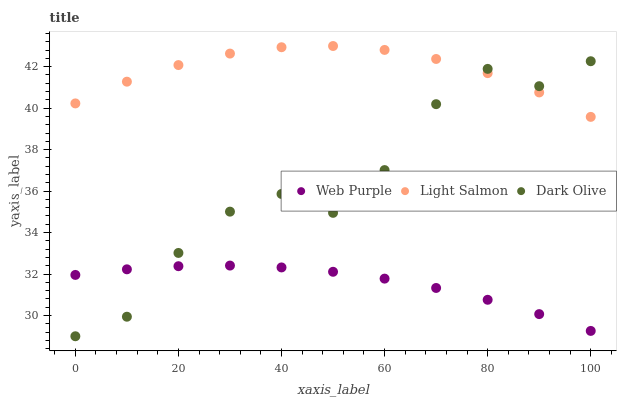Does Web Purple have the minimum area under the curve?
Answer yes or no. Yes. Does Light Salmon have the maximum area under the curve?
Answer yes or no. Yes. Does Dark Olive have the minimum area under the curve?
Answer yes or no. No. Does Dark Olive have the maximum area under the curve?
Answer yes or no. No. Is Web Purple the smoothest?
Answer yes or no. Yes. Is Dark Olive the roughest?
Answer yes or no. Yes. Is Light Salmon the smoothest?
Answer yes or no. No. Is Light Salmon the roughest?
Answer yes or no. No. Does Dark Olive have the lowest value?
Answer yes or no. Yes. Does Light Salmon have the lowest value?
Answer yes or no. No. Does Light Salmon have the highest value?
Answer yes or no. Yes. Does Dark Olive have the highest value?
Answer yes or no. No. Is Web Purple less than Light Salmon?
Answer yes or no. Yes. Is Light Salmon greater than Web Purple?
Answer yes or no. Yes. Does Dark Olive intersect Light Salmon?
Answer yes or no. Yes. Is Dark Olive less than Light Salmon?
Answer yes or no. No. Is Dark Olive greater than Light Salmon?
Answer yes or no. No. Does Web Purple intersect Light Salmon?
Answer yes or no. No. 